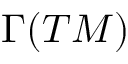Convert formula to latex. <formula><loc_0><loc_0><loc_500><loc_500>\Gamma ( T M )</formula> 